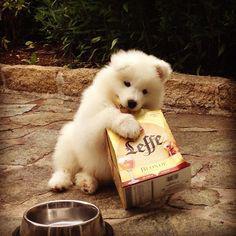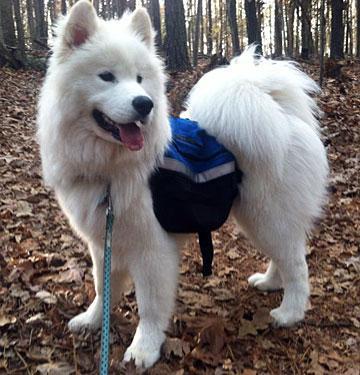The first image is the image on the left, the second image is the image on the right. For the images displayed, is the sentence "One image has a dog wearing more than just a collar or leash." factually correct? Answer yes or no. Yes. The first image is the image on the left, the second image is the image on the right. Examine the images to the left and right. Is the description "In at least one image you can see at least one human wearing jeans feeding no less than 6 white dogs." accurate? Answer yes or no. No. 